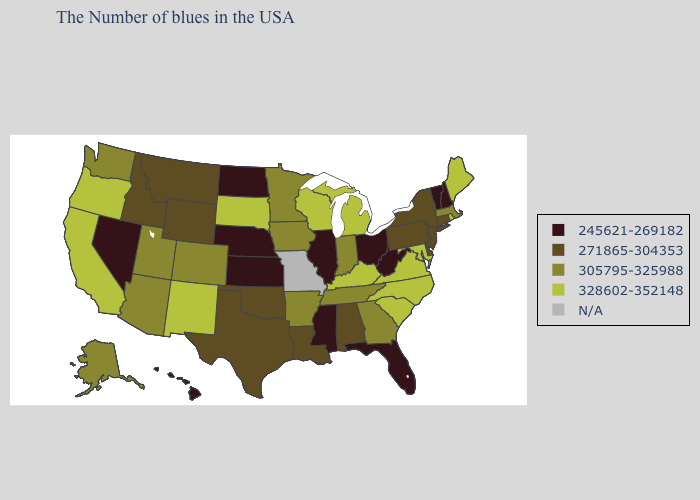Among the states that border Nebraska , which have the highest value?
Be succinct. South Dakota. Among the states that border Indiana , does Kentucky have the lowest value?
Quick response, please. No. Does the first symbol in the legend represent the smallest category?
Keep it brief. Yes. What is the highest value in the Northeast ?
Answer briefly. 328602-352148. Does Minnesota have the highest value in the USA?
Concise answer only. No. Among the states that border Michigan , does Indiana have the highest value?
Short answer required. No. Name the states that have a value in the range 305795-325988?
Keep it brief. Massachusetts, Georgia, Indiana, Tennessee, Arkansas, Minnesota, Iowa, Colorado, Utah, Arizona, Washington, Alaska. Name the states that have a value in the range N/A?
Concise answer only. Missouri. How many symbols are there in the legend?
Concise answer only. 5. Does Ohio have the highest value in the USA?
Answer briefly. No. Is the legend a continuous bar?
Give a very brief answer. No. Does the first symbol in the legend represent the smallest category?
Short answer required. Yes. Which states have the highest value in the USA?
Concise answer only. Maine, Rhode Island, Maryland, Virginia, North Carolina, South Carolina, Michigan, Kentucky, Wisconsin, South Dakota, New Mexico, California, Oregon. What is the value of Ohio?
Keep it brief. 245621-269182. What is the value of Texas?
Quick response, please. 271865-304353. 